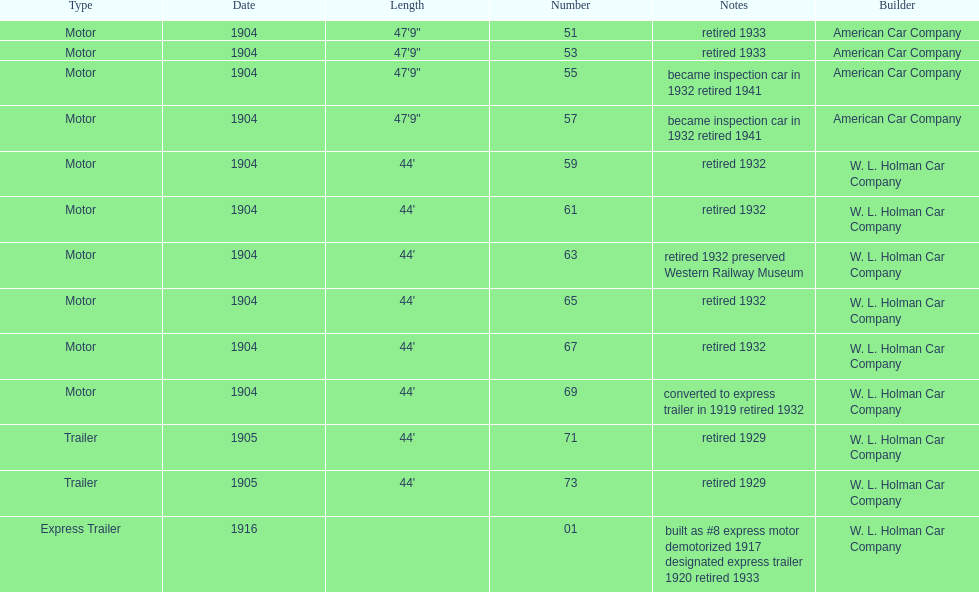Did american car company or w.l. holman car company build cars that were 44' in length? W. L. Holman Car Company. 